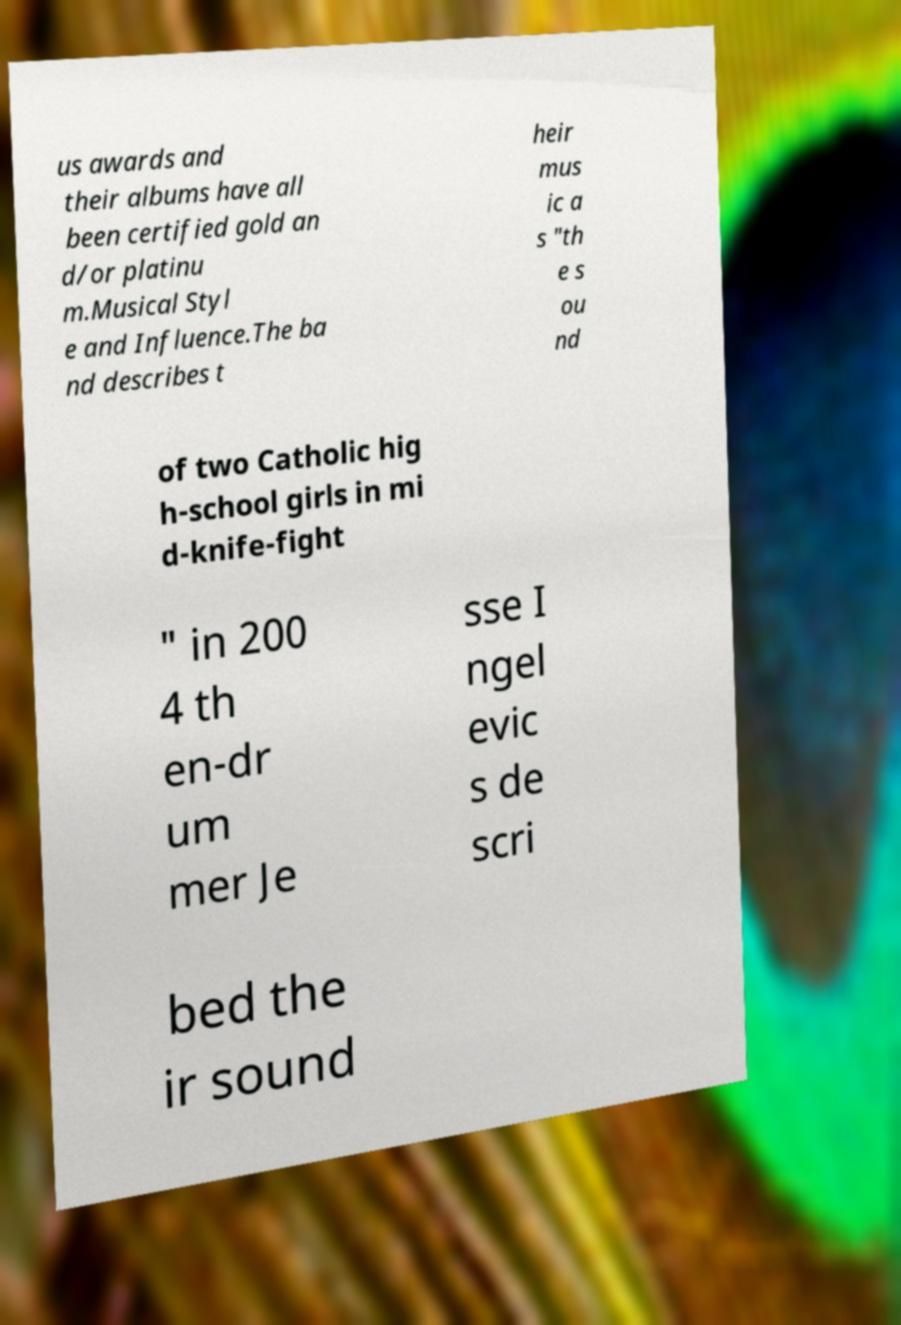Could you extract and type out the text from this image? us awards and their albums have all been certified gold an d/or platinu m.Musical Styl e and Influence.The ba nd describes t heir mus ic a s "th e s ou nd of two Catholic hig h-school girls in mi d-knife-fight " in 200 4 th en-dr um mer Je sse I ngel evic s de scri bed the ir sound 